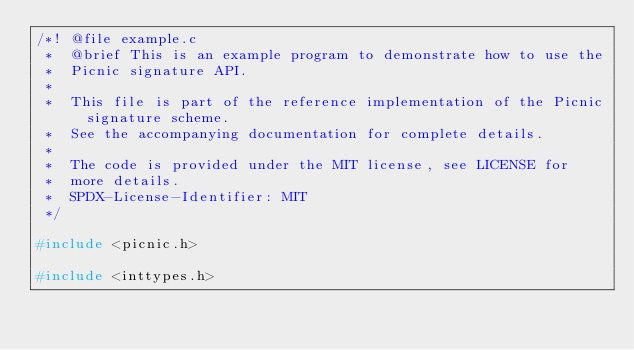Convert code to text. <code><loc_0><loc_0><loc_500><loc_500><_C_>/*! @file example.c
 *  @brief This is an example program to demonstrate how to use the
 *  Picnic signature API.
 *
 *  This file is part of the reference implementation of the Picnic signature scheme.
 *  See the accompanying documentation for complete details.
 *
 *  The code is provided under the MIT license, see LICENSE for
 *  more details.
 *  SPDX-License-Identifier: MIT
 */

#include <picnic.h>

#include <inttypes.h></code> 